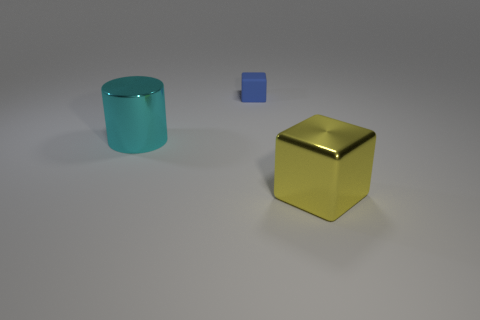Subtract all cylinders. How many objects are left? 2 Add 1 big cubes. How many objects exist? 4 Subtract all blue spheres. How many yellow blocks are left? 1 Add 1 tiny green cylinders. How many tiny green cylinders exist? 1 Subtract 1 cyan cylinders. How many objects are left? 2 Subtract 1 cubes. How many cubes are left? 1 Subtract all blue cubes. Subtract all purple spheres. How many cubes are left? 1 Subtract all blue matte objects. Subtract all large yellow objects. How many objects are left? 1 Add 3 cyan things. How many cyan things are left? 4 